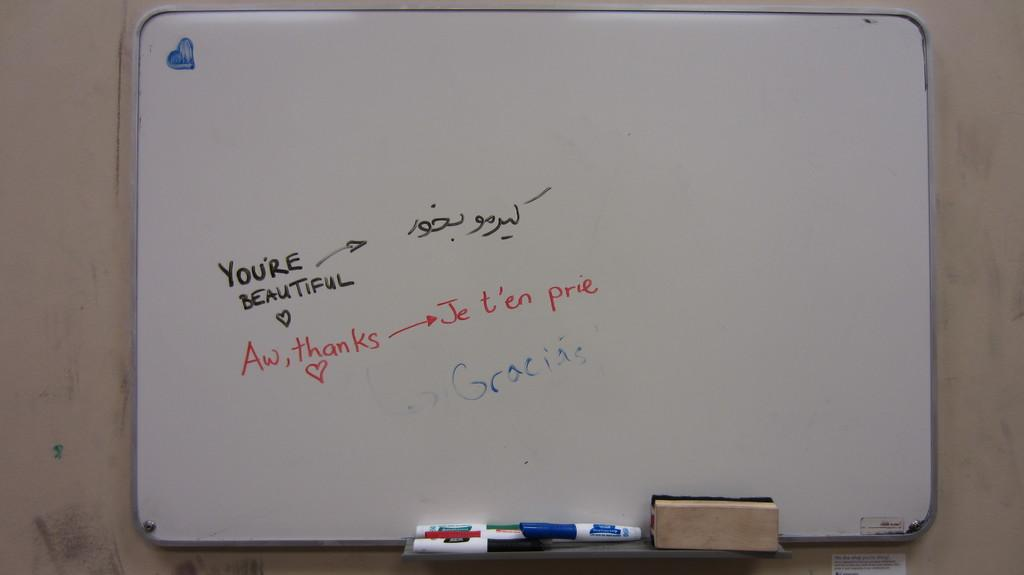<image>
Present a compact description of the photo's key features. Someone has written you're beautiful on a whiteboard. 